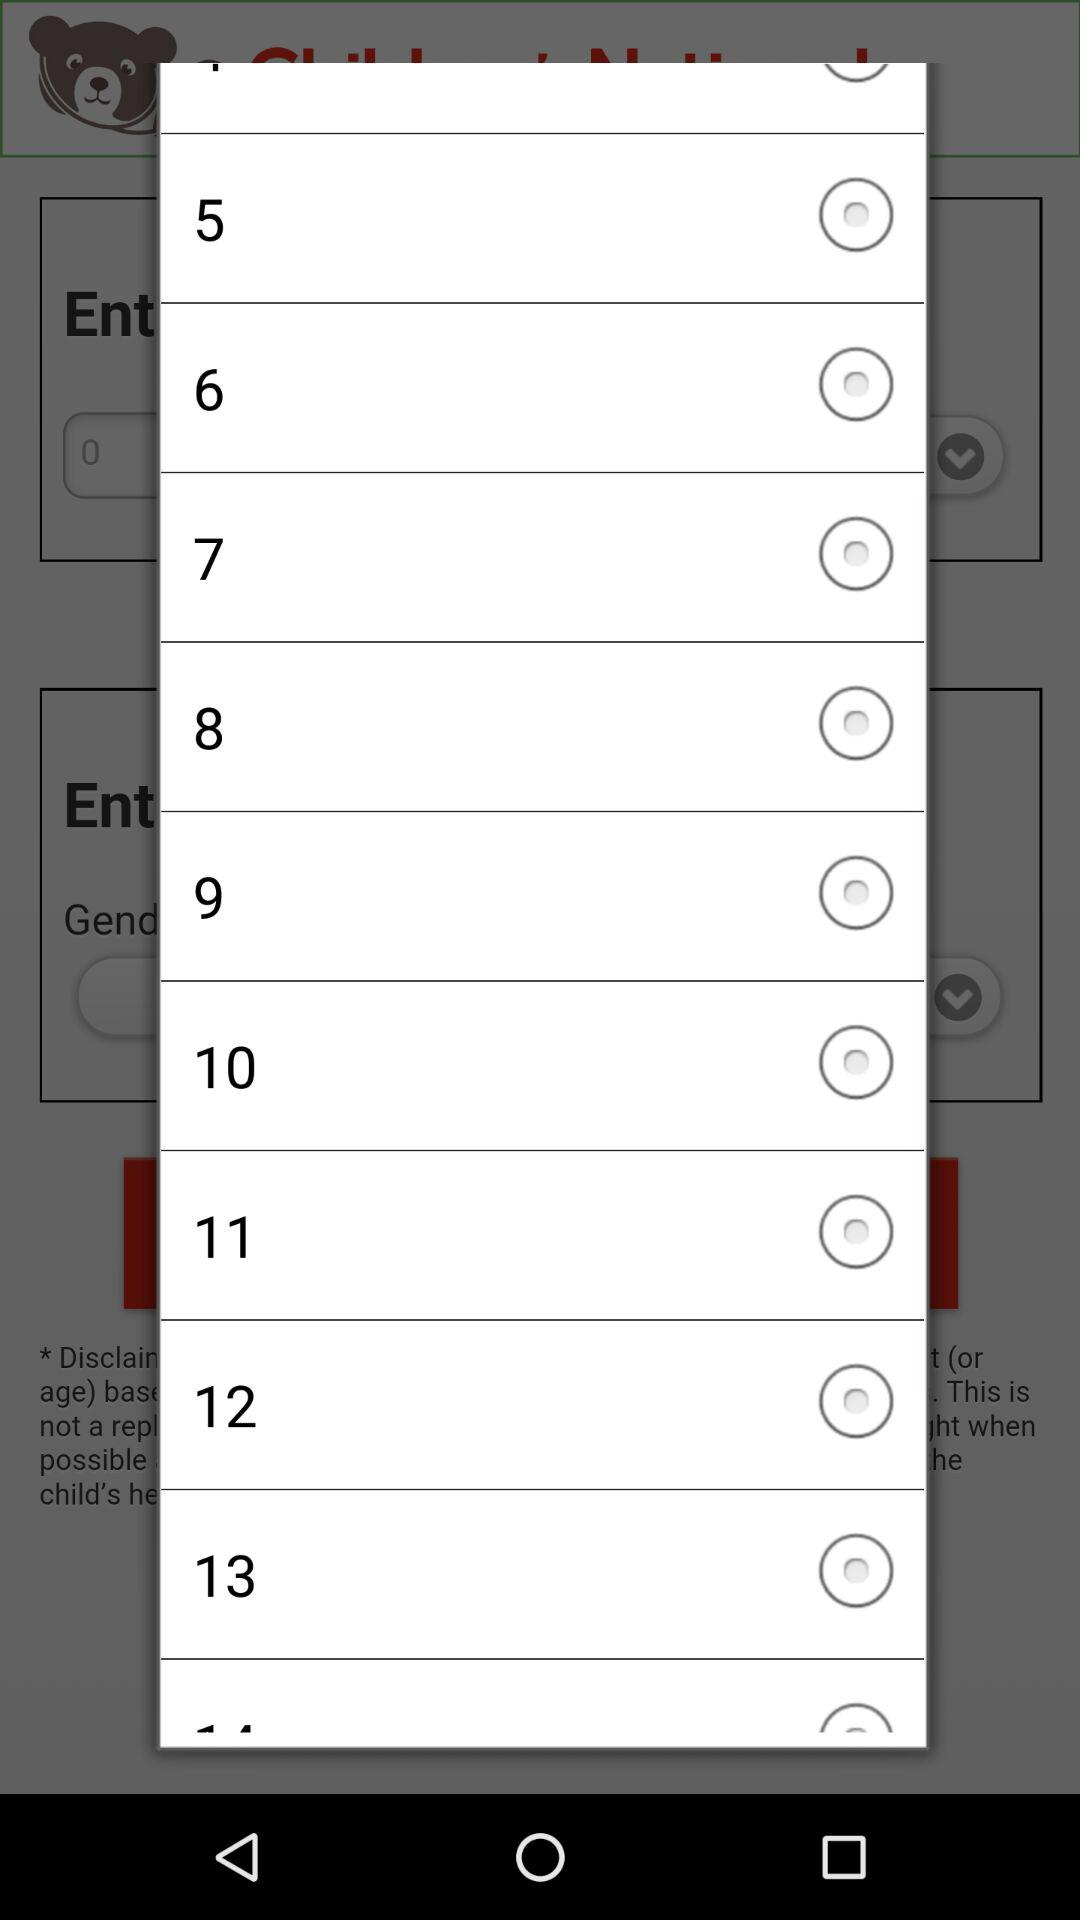Is radio button "6" selected or not? It is not selected. 